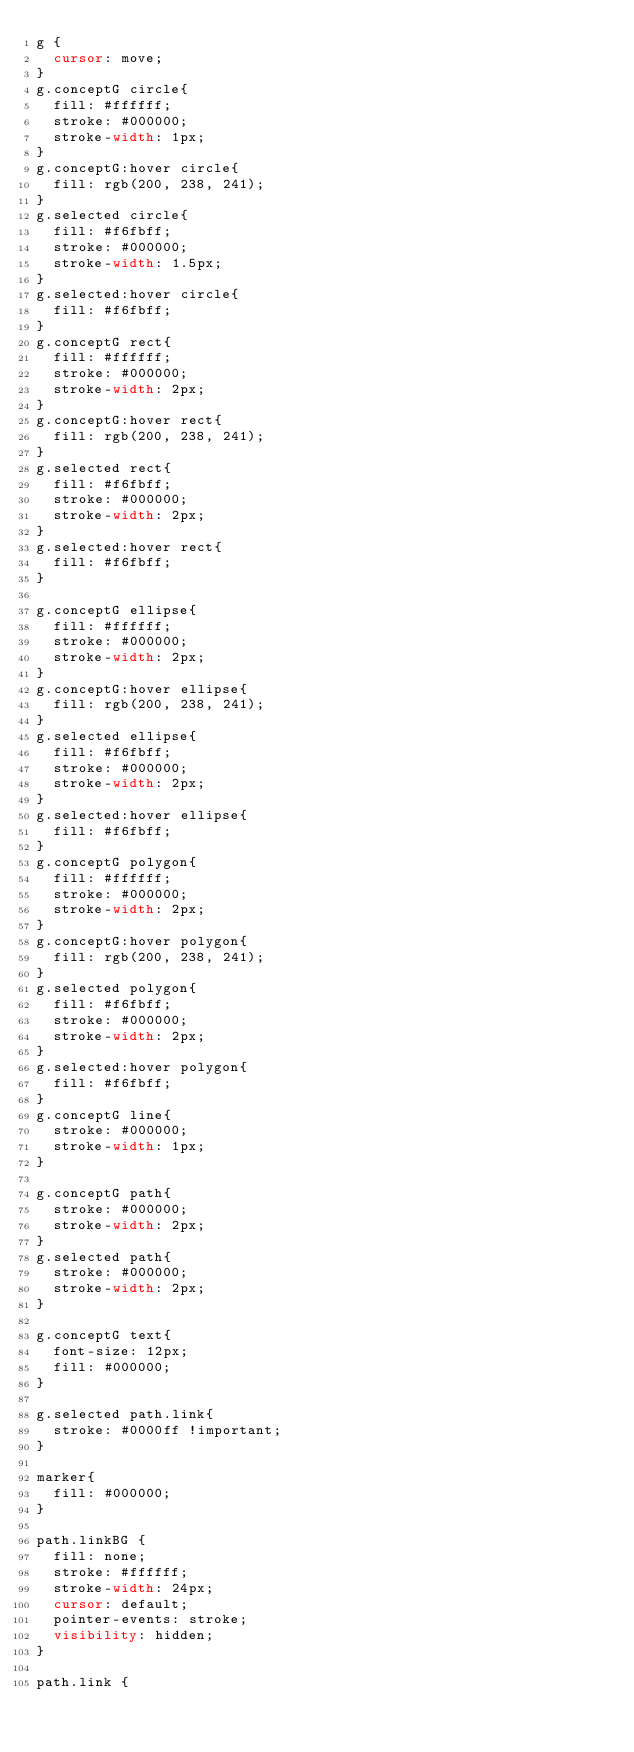Convert code to text. <code><loc_0><loc_0><loc_500><loc_500><_CSS_>g {
  cursor: move;
}
g.conceptG circle{
  fill: #ffffff;
  stroke: #000000;
  stroke-width: 1px;
}
g.conceptG:hover circle{
  fill: rgb(200, 238, 241);
}
g.selected circle{
  fill: #f6fbff;
  stroke: #000000;
  stroke-width: 1.5px;
}
g.selected:hover circle{
  fill: #f6fbff;
}
g.conceptG rect{
  fill: #ffffff;
  stroke: #000000;
  stroke-width: 2px;
}
g.conceptG:hover rect{
  fill: rgb(200, 238, 241);
}
g.selected rect{
  fill: #f6fbff;
  stroke: #000000;
  stroke-width: 2px;
}
g.selected:hover rect{
  fill: #f6fbff;
}

g.conceptG ellipse{
  fill: #ffffff;
  stroke: #000000;
  stroke-width: 2px;
}
g.conceptG:hover ellipse{
  fill: rgb(200, 238, 241);
}
g.selected ellipse{
  fill: #f6fbff;
  stroke: #000000;
  stroke-width: 2px;
}
g.selected:hover ellipse{
  fill: #f6fbff;
}
g.conceptG polygon{
  fill: #ffffff;
  stroke: #000000;
  stroke-width: 2px;
}
g.conceptG:hover polygon{
  fill: rgb(200, 238, 241);
}
g.selected polygon{
  fill: #f6fbff;
  stroke: #000000;
  stroke-width: 2px;
}
g.selected:hover polygon{
  fill: #f6fbff;
}
g.conceptG line{
  stroke: #000000;
  stroke-width: 1px;
}

g.conceptG path{
  stroke: #000000;
  stroke-width: 2px;
}
g.selected path{
  stroke: #000000;
  stroke-width: 2px;
}

g.conceptG text{    
  font-size: 12px;
  fill: #000000;
}

g.selected path.link{
  stroke: #0000ff !important;
}

marker{
  fill: #000000;
}

path.linkBG {
  fill: none;
  stroke: #ffffff;
  stroke-width: 24px;
  cursor: default;
  pointer-events: stroke;
  visibility: hidden;
}

path.link {</code> 